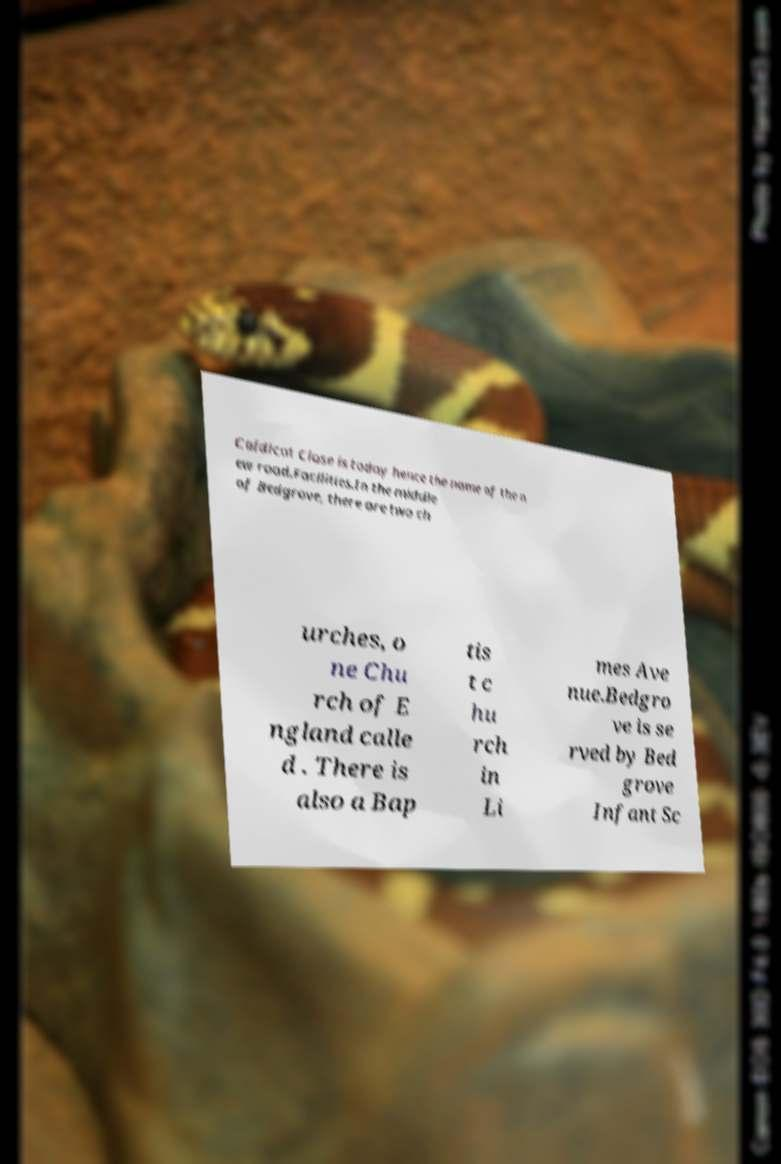I need the written content from this picture converted into text. Can you do that? Caldicot Close is today hence the name of the n ew road.Facilities.In the middle of Bedgrove, there are two ch urches, o ne Chu rch of E ngland calle d . There is also a Bap tis t c hu rch in Li mes Ave nue.Bedgro ve is se rved by Bed grove Infant Sc 